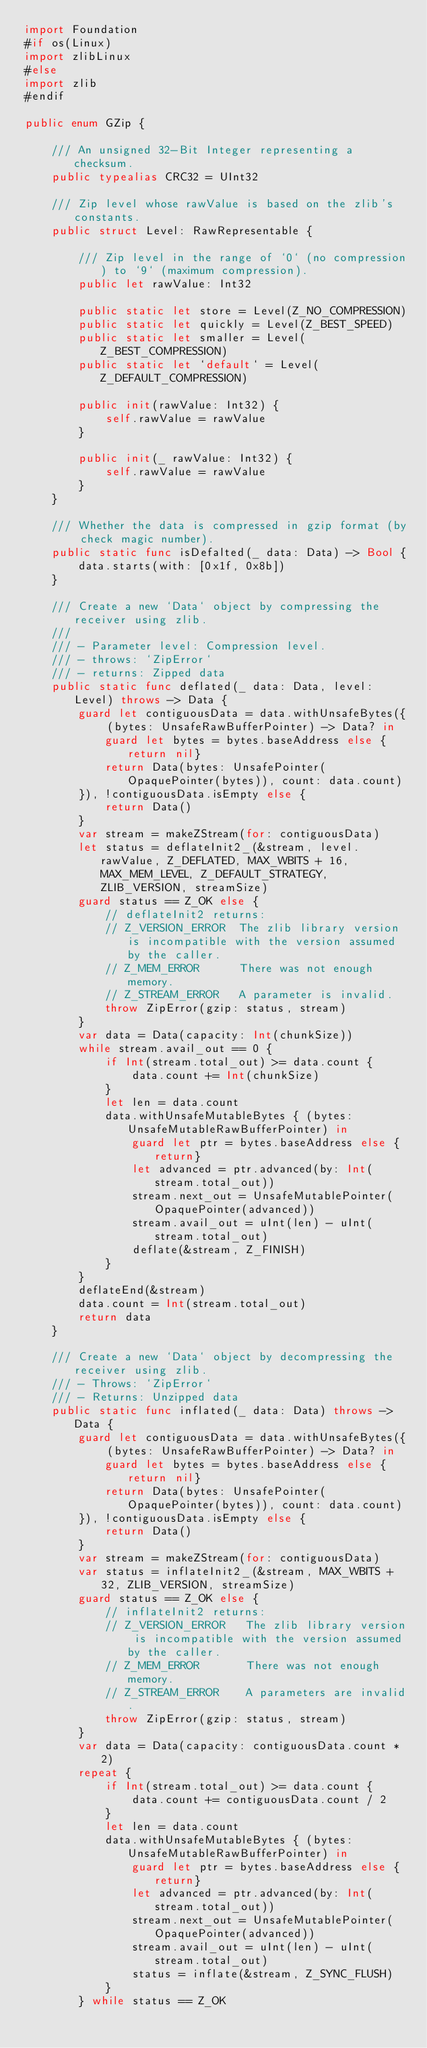Convert code to text. <code><loc_0><loc_0><loc_500><loc_500><_Swift_>import Foundation
#if os(Linux)
import zlibLinux
#else
import zlib
#endif

public enum GZip {

	/// An unsigned 32-Bit Integer representing a checksum.
	public typealias CRC32 = UInt32

	/// Zip level whose rawValue is based on the zlib's constants.
	public struct Level: RawRepresentable {
		
		/// Zip level in the range of `0` (no compression) to `9` (maximum compression).
		public let rawValue: Int32
		
		public static let store = Level(Z_NO_COMPRESSION)
		public static let quickly = Level(Z_BEST_SPEED)
		public static let smaller = Level(Z_BEST_COMPRESSION)
		public static let `default` = Level(Z_DEFAULT_COMPRESSION)
		
		public init(rawValue: Int32) {
			self.rawValue = rawValue
		}
		
		public init(_ rawValue: Int32) {
			self.rawValue = rawValue
		}
	}
	
	/// Whether the data is compressed in gzip format (by check magic number).
	public static func isDefalted(_ data: Data) -> Bool {
		data.starts(with: [0x1f, 0x8b])
	}
	
	/// Create a new `Data` object by compressing the receiver using zlib.
	///
	/// - Parameter level: Compression level.
	/// - throws: `ZipError`
	/// - returns: Zipped data
	public static func deflated(_ data: Data, level: Level) throws -> Data {
		guard let contiguousData = data.withUnsafeBytes({ (bytes: UnsafeRawBufferPointer) -> Data? in
			guard let bytes = bytes.baseAddress else {return nil}
			return Data(bytes: UnsafePointer(OpaquePointer(bytes)), count: data.count)
		}), !contiguousData.isEmpty else {
			return Data()
		}
		var stream = makeZStream(for: contiguousData)
		let status = deflateInit2_(&stream, level.rawValue, Z_DEFLATED, MAX_WBITS + 16, MAX_MEM_LEVEL, Z_DEFAULT_STRATEGY, ZLIB_VERSION, streamSize)
		guard status == Z_OK else {
			// deflateInit2 returns:
			// Z_VERSION_ERROR  The zlib library version is incompatible with the version assumed by the caller.
			// Z_MEM_ERROR      There was not enough memory.
			// Z_STREAM_ERROR   A parameter is invalid.
			throw ZipError(gzip: status, stream)
		}
		var data = Data(capacity: Int(chunkSize))
		while stream.avail_out == 0 {
			if Int(stream.total_out) >= data.count {
				data.count += Int(chunkSize)
			}
			let len = data.count
			data.withUnsafeMutableBytes { (bytes: UnsafeMutableRawBufferPointer) in
				guard let ptr = bytes.baseAddress else {return}
				let advanced = ptr.advanced(by: Int(stream.total_out))
				stream.next_out = UnsafeMutablePointer(OpaquePointer(advanced))
				stream.avail_out = uInt(len) - uInt(stream.total_out)
				deflate(&stream, Z_FINISH)
			}
		}
		deflateEnd(&stream)
		data.count = Int(stream.total_out)
		return data
	}
	
	/// Create a new `Data` object by decompressing the receiver using zlib.
	/// - Throws: `ZipError`
	/// - Returns: Unzipped data
	public static func inflated(_ data: Data) throws -> Data {
		guard let contiguousData = data.withUnsafeBytes({ (bytes: UnsafeRawBufferPointer) -> Data? in
			guard let bytes = bytes.baseAddress else {return nil}
			return Data(bytes: UnsafePointer(OpaquePointer(bytes)), count: data.count)
		}), !contiguousData.isEmpty else {
			return Data()
		}
		var stream = makeZStream(for: contiguousData)
		var status = inflateInit2_(&stream, MAX_WBITS + 32, ZLIB_VERSION, streamSize)
		guard status == Z_OK else {
			// inflateInit2 returns:
			// Z_VERSION_ERROR   The zlib library version is incompatible with the version assumed by the caller.
			// Z_MEM_ERROR       There was not enough memory.
			// Z_STREAM_ERROR    A parameters are invalid.
			throw ZipError(gzip: status, stream)
		}
		var data = Data(capacity: contiguousData.count * 2)
		repeat {
			if Int(stream.total_out) >= data.count {
				data.count += contiguousData.count / 2
			}
			let len = data.count
			data.withUnsafeMutableBytes { (bytes: UnsafeMutableRawBufferPointer) in
				guard let ptr = bytes.baseAddress else {return}
				let advanced = ptr.advanced(by: Int(stream.total_out))
				stream.next_out = UnsafeMutablePointer(OpaquePointer(advanced))
				stream.avail_out = uInt(len) - uInt(stream.total_out)
				status = inflate(&stream, Z_SYNC_FLUSH)
			}
		} while status == Z_OK</code> 